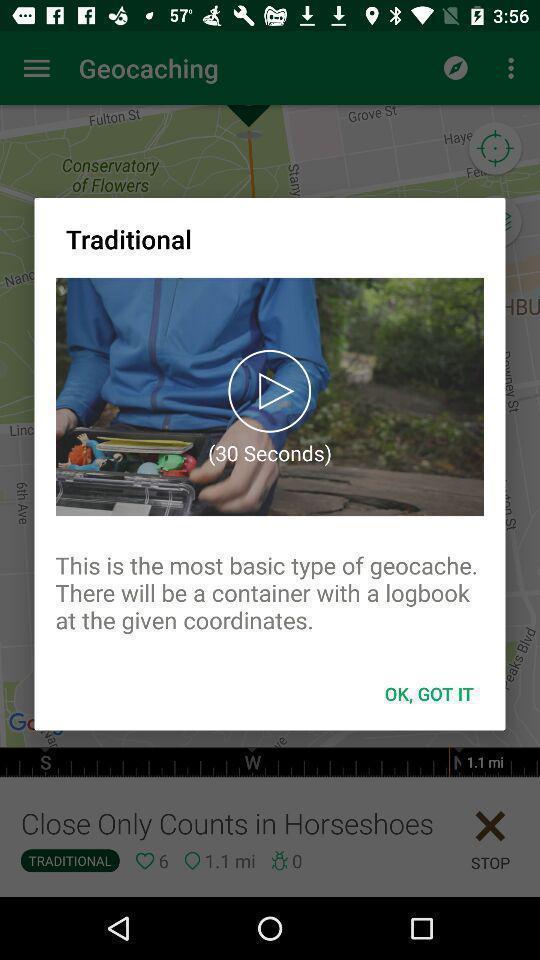Describe this image in words. Window displaying an adventure app. 